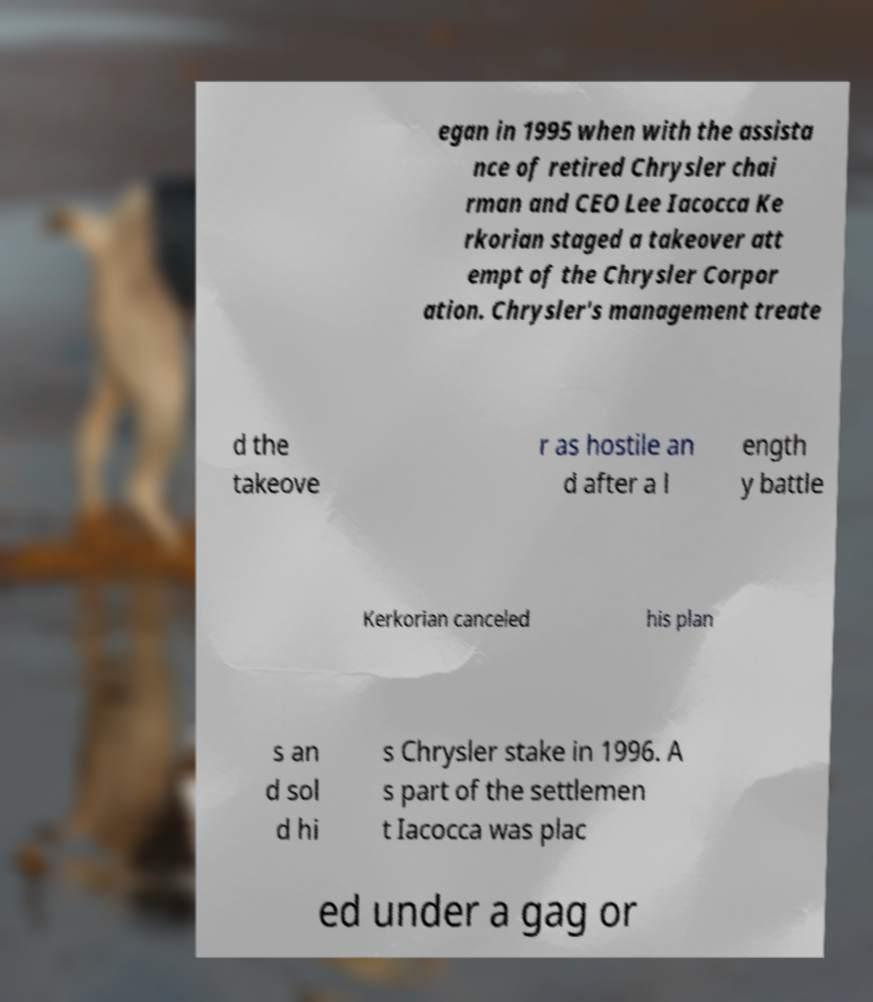What messages or text are displayed in this image? I need them in a readable, typed format. egan in 1995 when with the assista nce of retired Chrysler chai rman and CEO Lee Iacocca Ke rkorian staged a takeover att empt of the Chrysler Corpor ation. Chrysler's management treate d the takeove r as hostile an d after a l ength y battle Kerkorian canceled his plan s an d sol d hi s Chrysler stake in 1996. A s part of the settlemen t Iacocca was plac ed under a gag or 